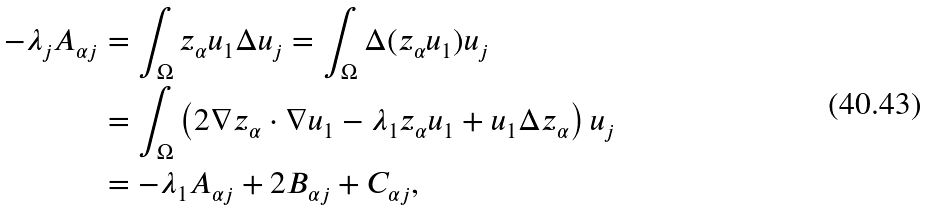<formula> <loc_0><loc_0><loc_500><loc_500>- \lambda _ { j } A _ { \alpha j } & = \int _ { \Omega } z _ { \alpha } u _ { 1 } \Delta u _ { j } = \int _ { \Omega } \Delta ( z _ { \alpha } u _ { 1 } ) u _ { j } \\ & = \int _ { \Omega } \left ( 2 \nabla z _ { \alpha } \cdot \nabla u _ { 1 } - \lambda _ { 1 } z _ { \alpha } u _ { 1 } + u _ { 1 } \Delta z _ { \alpha } \right ) u _ { j } \\ & = - \lambda _ { 1 } A _ { \alpha j } + 2 B _ { \alpha j } + C _ { \alpha j } ,</formula> 